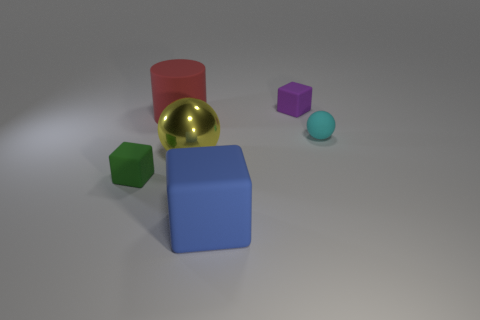Are there any other things that have the same material as the tiny cyan thing?
Provide a succinct answer. Yes. How many small objects are gray matte balls or blue blocks?
Give a very brief answer. 0. Does the big rubber thing behind the blue rubber object have the same shape as the tiny green object?
Ensure brevity in your answer.  No. Are there fewer large yellow things than big brown rubber things?
Give a very brief answer. No. Are there any other things that are the same color as the big rubber cylinder?
Make the answer very short. No. The large rubber thing that is in front of the big red matte object has what shape?
Your response must be concise. Cube. Is the color of the small sphere the same as the cube to the left of the yellow thing?
Your answer should be very brief. No. Are there an equal number of tiny cyan spheres that are on the left side of the tiny purple cube and red rubber objects that are in front of the green matte thing?
Provide a short and direct response. Yes. What number of other things are there of the same size as the cylinder?
Provide a short and direct response. 2. How big is the cyan rubber sphere?
Keep it short and to the point. Small. 